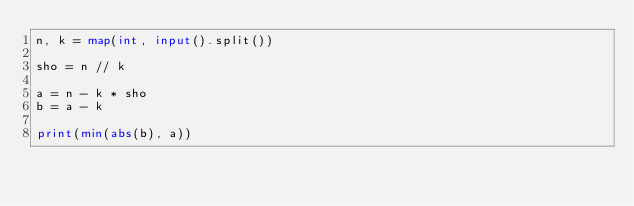Convert code to text. <code><loc_0><loc_0><loc_500><loc_500><_Python_>n, k = map(int, input().split())

sho = n // k

a = n - k * sho
b = a - k

print(min(abs(b), a))</code> 